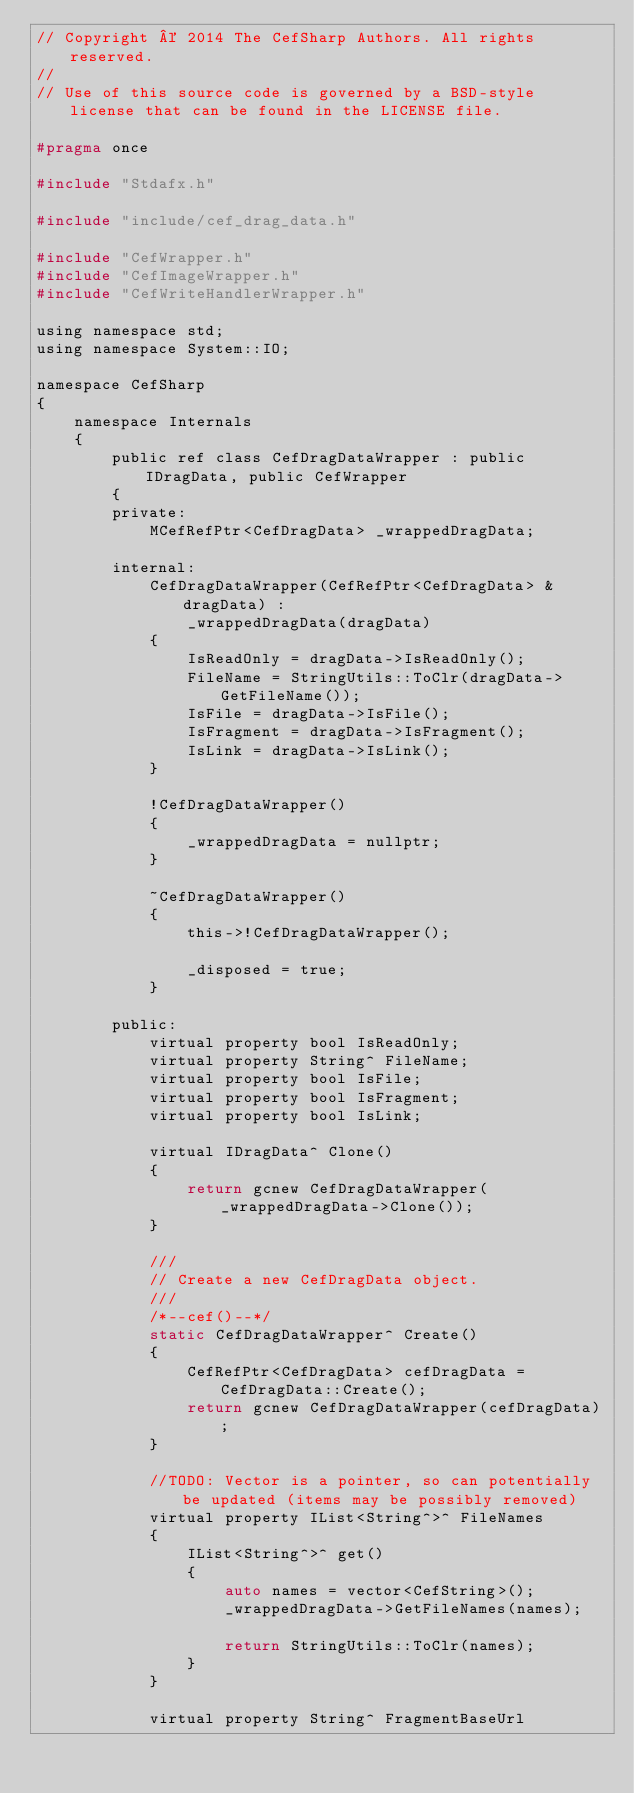<code> <loc_0><loc_0><loc_500><loc_500><_C_>// Copyright © 2014 The CefSharp Authors. All rights reserved.
//
// Use of this source code is governed by a BSD-style license that can be found in the LICENSE file.

#pragma once

#include "Stdafx.h"

#include "include/cef_drag_data.h"

#include "CefWrapper.h"
#include "CefImageWrapper.h"
#include "CefWriteHandlerWrapper.h"

using namespace std;
using namespace System::IO;

namespace CefSharp
{
    namespace Internals
    {
        public ref class CefDragDataWrapper : public IDragData, public CefWrapper
        {
        private:
            MCefRefPtr<CefDragData> _wrappedDragData;

        internal:
            CefDragDataWrapper(CefRefPtr<CefDragData> &dragData) :
                _wrappedDragData(dragData)
            {
                IsReadOnly = dragData->IsReadOnly();
                FileName = StringUtils::ToClr(dragData->GetFileName());
                IsFile = dragData->IsFile();
                IsFragment = dragData->IsFragment();
                IsLink = dragData->IsLink();
            }

            !CefDragDataWrapper()
            {
                _wrappedDragData = nullptr;
            }

            ~CefDragDataWrapper()
            {
                this->!CefDragDataWrapper();

                _disposed = true;
            }

        public:
            virtual property bool IsReadOnly;
            virtual property String^ FileName;
            virtual property bool IsFile;
            virtual property bool IsFragment;
            virtual property bool IsLink;

            virtual IDragData^ Clone()
            {
                return gcnew CefDragDataWrapper(_wrappedDragData->Clone());
            }

            ///
            // Create a new CefDragData object.
            ///
            /*--cef()--*/
            static CefDragDataWrapper^ Create()
            {
                CefRefPtr<CefDragData> cefDragData = CefDragData::Create();
                return gcnew CefDragDataWrapper(cefDragData);
            }

            //TODO: Vector is a pointer, so can potentially be updated (items may be possibly removed)
            virtual property IList<String^>^ FileNames
            {
                IList<String^>^ get()
                {
                    auto names = vector<CefString>();
                    _wrappedDragData->GetFileNames(names);

                    return StringUtils::ToClr(names);
                }
            }

            virtual property String^ FragmentBaseUrl</code> 